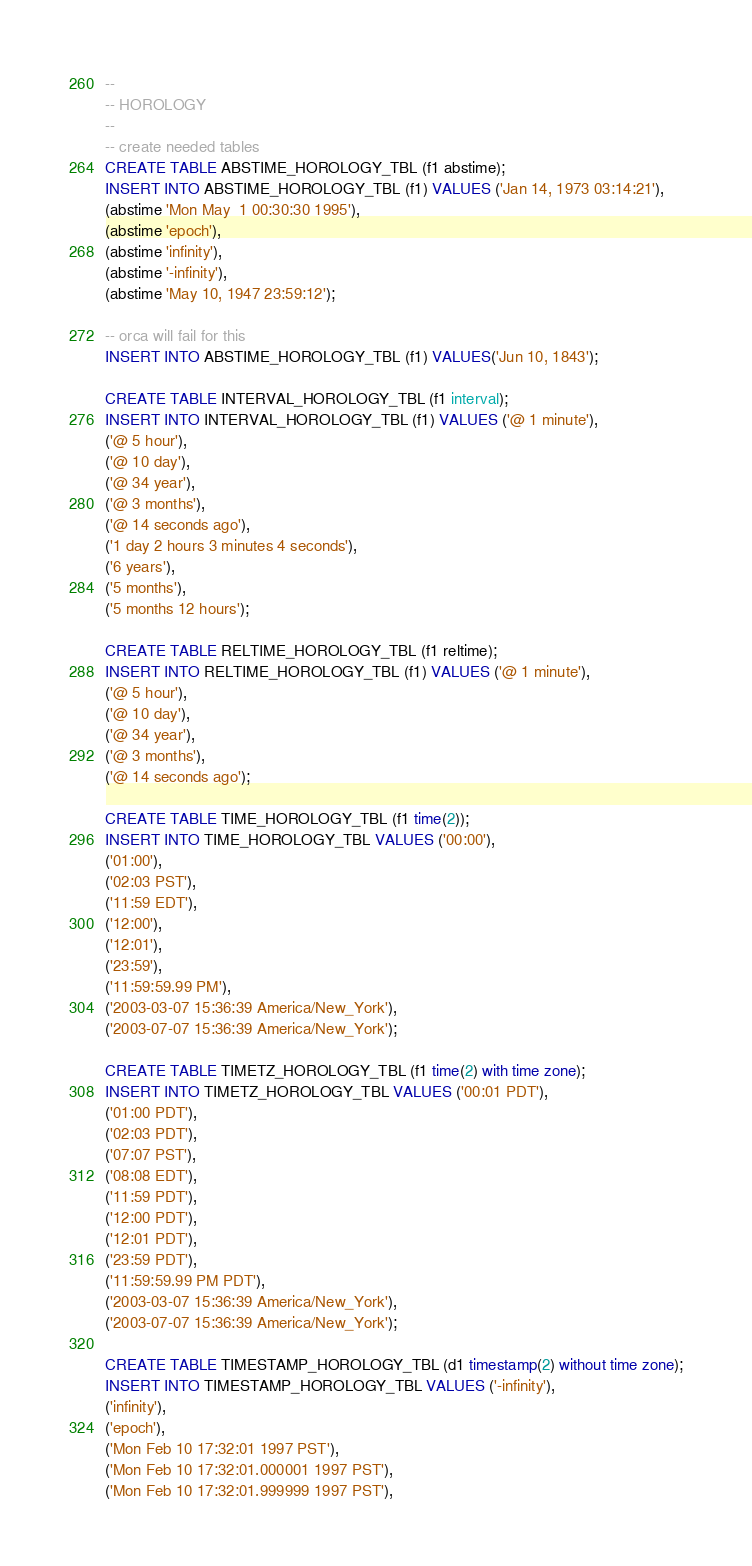<code> <loc_0><loc_0><loc_500><loc_500><_SQL_>--
-- HOROLOGY
--
-- create needed tables
CREATE TABLE ABSTIME_HOROLOGY_TBL (f1 abstime);
INSERT INTO ABSTIME_HOROLOGY_TBL (f1) VALUES ('Jan 14, 1973 03:14:21'),
(abstime 'Mon May  1 00:30:30 1995'),
(abstime 'epoch'),
(abstime 'infinity'),
(abstime '-infinity'),
(abstime 'May 10, 1947 23:59:12');

-- orca will fail for this
INSERT INTO ABSTIME_HOROLOGY_TBL (f1) VALUES('Jun 10, 1843');

CREATE TABLE INTERVAL_HOROLOGY_TBL (f1 interval);
INSERT INTO INTERVAL_HOROLOGY_TBL (f1) VALUES ('@ 1 minute'),
('@ 5 hour'),
('@ 10 day'),
('@ 34 year'),
('@ 3 months'),
('@ 14 seconds ago'),
('1 day 2 hours 3 minutes 4 seconds'),
('6 years'),
('5 months'),
('5 months 12 hours');

CREATE TABLE RELTIME_HOROLOGY_TBL (f1 reltime);
INSERT INTO RELTIME_HOROLOGY_TBL (f1) VALUES ('@ 1 minute'),
('@ 5 hour'),
('@ 10 day'),
('@ 34 year'),
('@ 3 months'),
('@ 14 seconds ago');

CREATE TABLE TIME_HOROLOGY_TBL (f1 time(2));
INSERT INTO TIME_HOROLOGY_TBL VALUES ('00:00'),
('01:00'),
('02:03 PST'),
('11:59 EDT'),
('12:00'),
('12:01'),
('23:59'),
('11:59:59.99 PM'),
('2003-03-07 15:36:39 America/New_York'),
('2003-07-07 15:36:39 America/New_York');

CREATE TABLE TIMETZ_HOROLOGY_TBL (f1 time(2) with time zone);
INSERT INTO TIMETZ_HOROLOGY_TBL VALUES ('00:01 PDT'),
('01:00 PDT'),
('02:03 PDT'),
('07:07 PST'),
('08:08 EDT'),
('11:59 PDT'),
('12:00 PDT'),
('12:01 PDT'),
('23:59 PDT'),
('11:59:59.99 PM PDT'),
('2003-03-07 15:36:39 America/New_York'),
('2003-07-07 15:36:39 America/New_York');

CREATE TABLE TIMESTAMP_HOROLOGY_TBL (d1 timestamp(2) without time zone);
INSERT INTO TIMESTAMP_HOROLOGY_TBL VALUES ('-infinity'),
('infinity'),
('epoch'),
('Mon Feb 10 17:32:01 1997 PST'),
('Mon Feb 10 17:32:01.000001 1997 PST'),
('Mon Feb 10 17:32:01.999999 1997 PST'),</code> 